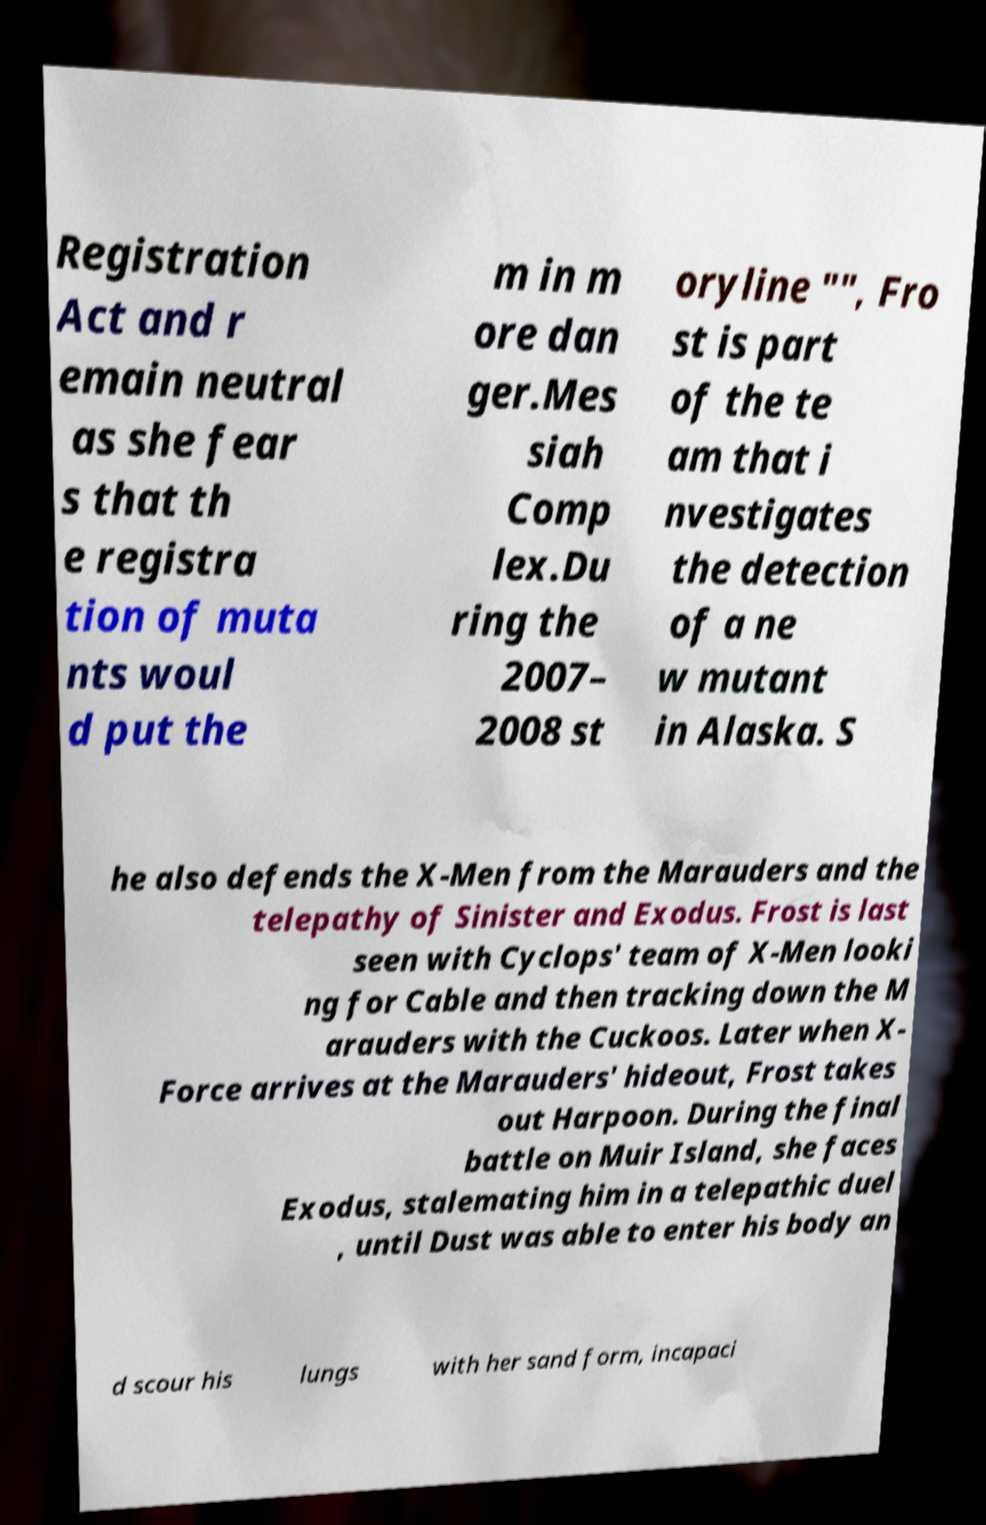Can you accurately transcribe the text from the provided image for me? Registration Act and r emain neutral as she fear s that th e registra tion of muta nts woul d put the m in m ore dan ger.Mes siah Comp lex.Du ring the 2007– 2008 st oryline "", Fro st is part of the te am that i nvestigates the detection of a ne w mutant in Alaska. S he also defends the X-Men from the Marauders and the telepathy of Sinister and Exodus. Frost is last seen with Cyclops' team of X-Men looki ng for Cable and then tracking down the M arauders with the Cuckoos. Later when X- Force arrives at the Marauders' hideout, Frost takes out Harpoon. During the final battle on Muir Island, she faces Exodus, stalemating him in a telepathic duel , until Dust was able to enter his body an d scour his lungs with her sand form, incapaci 